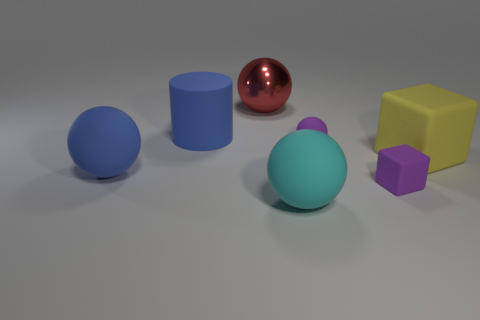Subtract all big spheres. How many spheres are left? 1 Add 2 large blue shiny cubes. How many objects exist? 9 Subtract all cyan spheres. How many spheres are left? 3 Subtract all balls. How many objects are left? 3 Subtract 2 spheres. How many spheres are left? 2 Subtract 0 red cubes. How many objects are left? 7 Subtract all blue blocks. Subtract all green cylinders. How many blocks are left? 2 Subtract all large cylinders. Subtract all large yellow things. How many objects are left? 5 Add 2 small cubes. How many small cubes are left? 3 Add 2 large blue objects. How many large blue objects exist? 4 